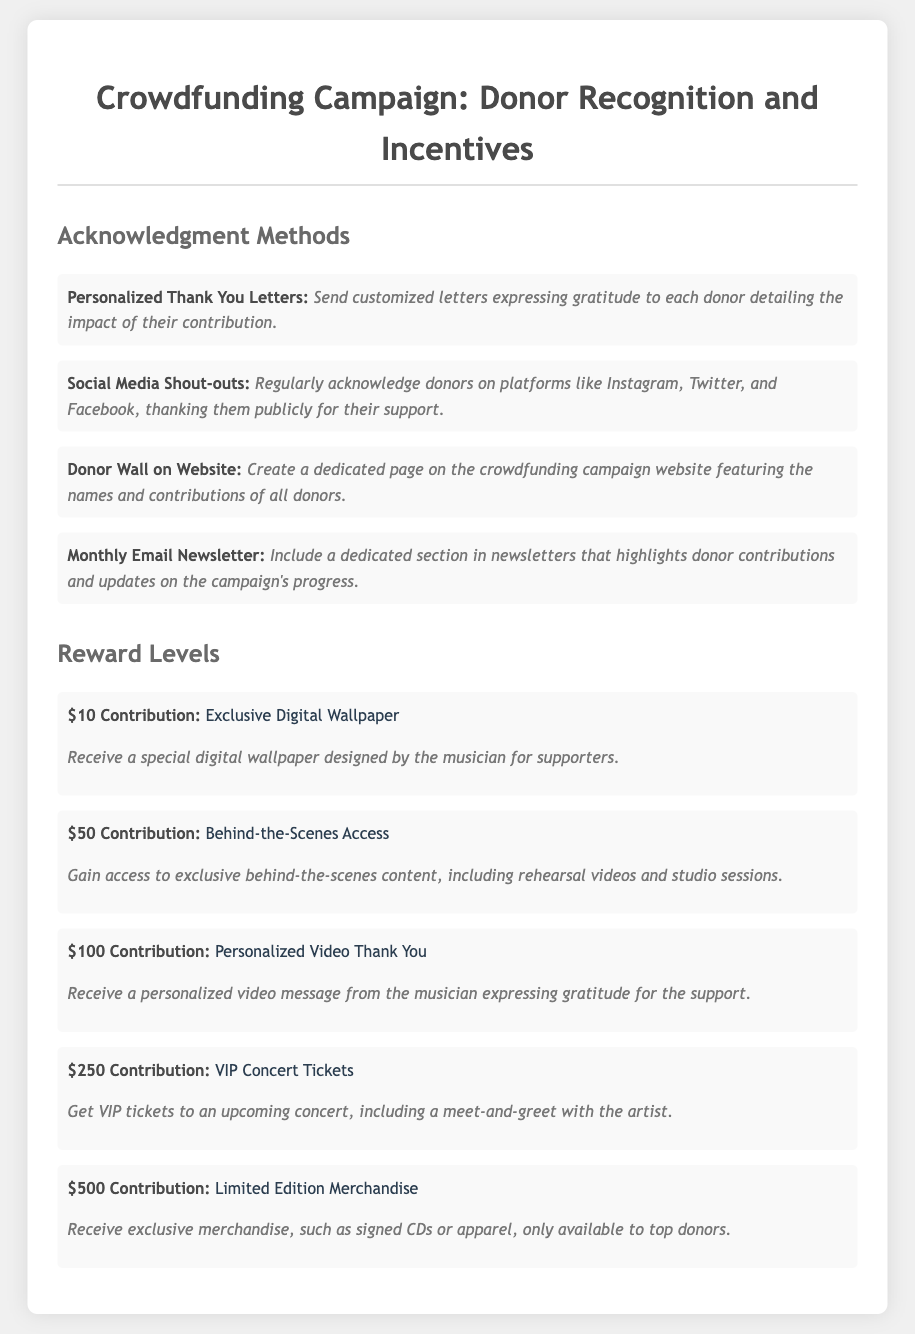what is the first method of acknowledgment? The document lists "Personalized Thank You Letters" as the first method of acknowledgment for donors.
Answer: Personalized Thank You Letters what is the reward for a $100 contribution? According to the document, a $100 contribution provides the donor with a "Personalized Video Thank You."
Answer: Personalized Video Thank You how many acknowledgment methods are listed in the document? The document lists four acknowledgment methods.
Answer: 4 what is the description of the $250 contribution reward? The description for the $250 contribution reward mentions receiving VIP tickets to an upcoming concert and includes a meet-and-greet with the artist.
Answer: Get VIP tickets to an upcoming concert, including a meet-and-greet with the artist where can donors' names be featured online? The "Donor Wall on Website" is mentioned as a place where donors' names can be featured online.
Answer: Donor Wall on Website what form of acknowledgment is done through social media? The document states that social media shout-outs are a form of acknowledgment provided to donors.
Answer: Social Media Shout-outs what supporters receive exclusive behind-the-scenes content? Supporters who contribute $50 receive access to exclusive behind-the-scenes content.
Answer: $50 Contribution what type of merchandise is offered at the $500 contribution level? The document mentions "Limited Edition Merchandise," such as signed CDs or apparel, for the $500 contribution level.
Answer: Limited Edition Merchandise 